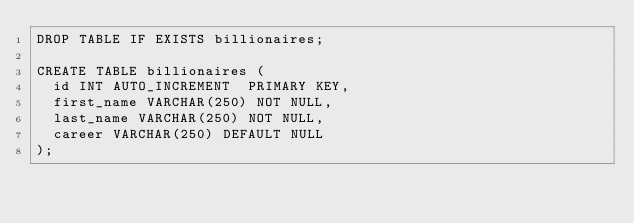Convert code to text. <code><loc_0><loc_0><loc_500><loc_500><_SQL_>DROP TABLE IF EXISTS billionaires;

CREATE TABLE billionaires (
  id INT AUTO_INCREMENT  PRIMARY KEY,
  first_name VARCHAR(250) NOT NULL,
  last_name VARCHAR(250) NOT NULL,
  career VARCHAR(250) DEFAULT NULL
);</code> 